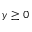Convert formula to latex. <formula><loc_0><loc_0><loc_500><loc_500>y \geq 0</formula> 